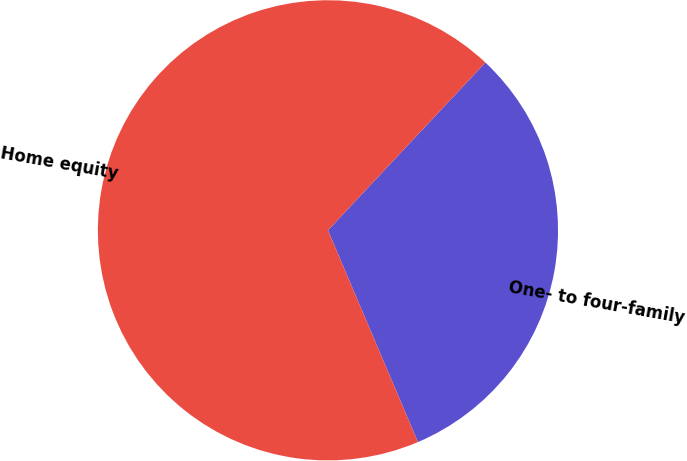<chart> <loc_0><loc_0><loc_500><loc_500><pie_chart><fcel>One- to four-family<fcel>Home equity<nl><fcel>31.61%<fcel>68.39%<nl></chart> 